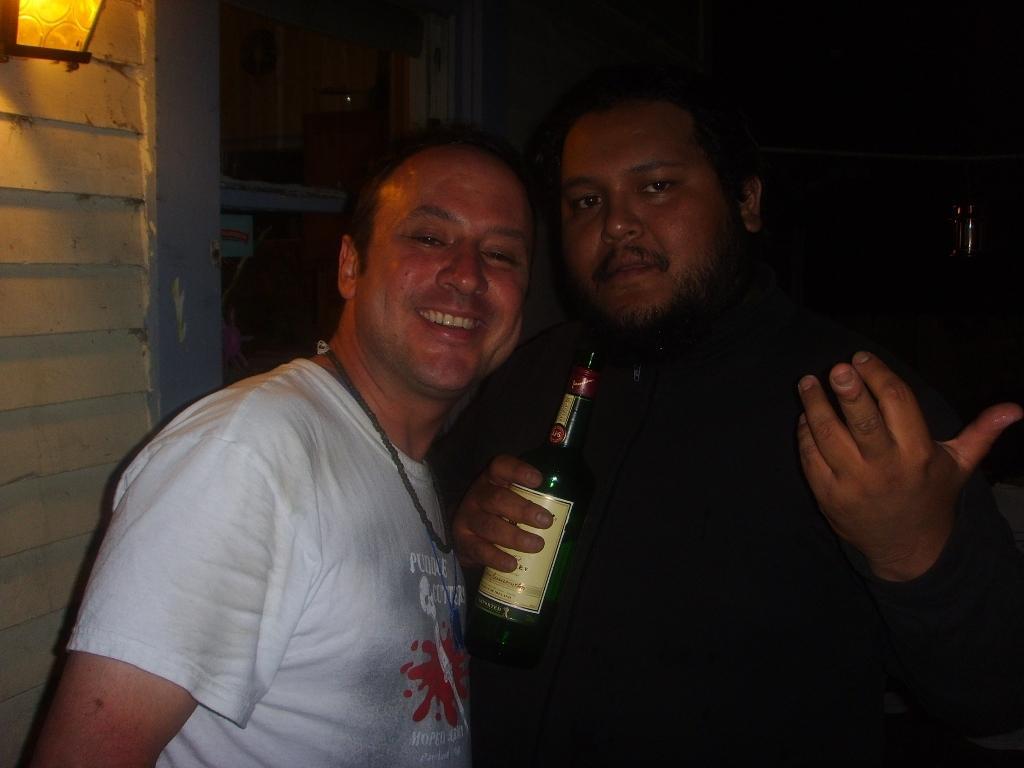Describe this image in one or two sentences. There are two people,he is smiling,he is holding a wine bottle in his hand. On the left we see a wall and at the top of left there is a light. 